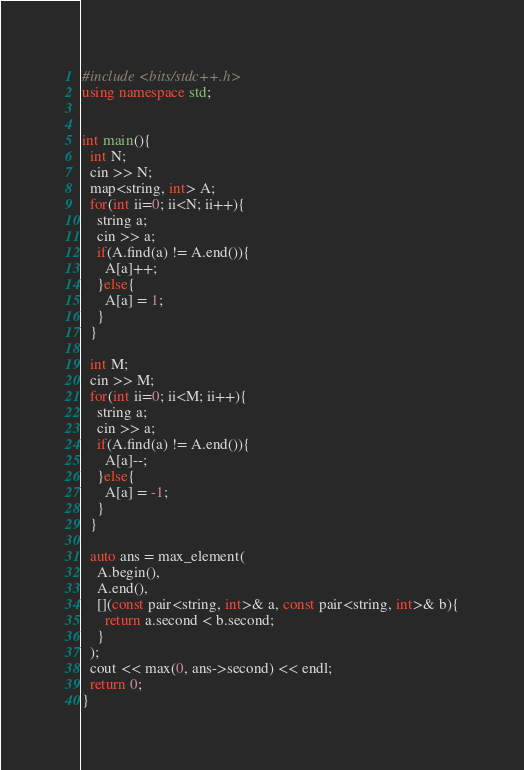<code> <loc_0><loc_0><loc_500><loc_500><_C++_>#include <bits/stdc++.h>
using namespace std;


int main(){
  int N;
  cin >> N;
  map<string, int> A;
  for(int ii=0; ii<N; ii++){
    string a;
    cin >> a;
    if(A.find(a) != A.end()){
      A[a]++;
    }else{
      A[a] = 1;
    }
  }
  
  int M;
  cin >> M;
  for(int ii=0; ii<M; ii++){
    string a;
    cin >> a;
    if(A.find(a) != A.end()){
      A[a]--;
    }else{
      A[a] = -1;
    }
  }
  
  auto ans = max_element(
    A.begin(),
    A.end(),
    [](const pair<string, int>& a, const pair<string, int>& b){
      return a.second < b.second;
    }
  );
  cout << max(0, ans->second) << endl;
  return 0;
}</code> 